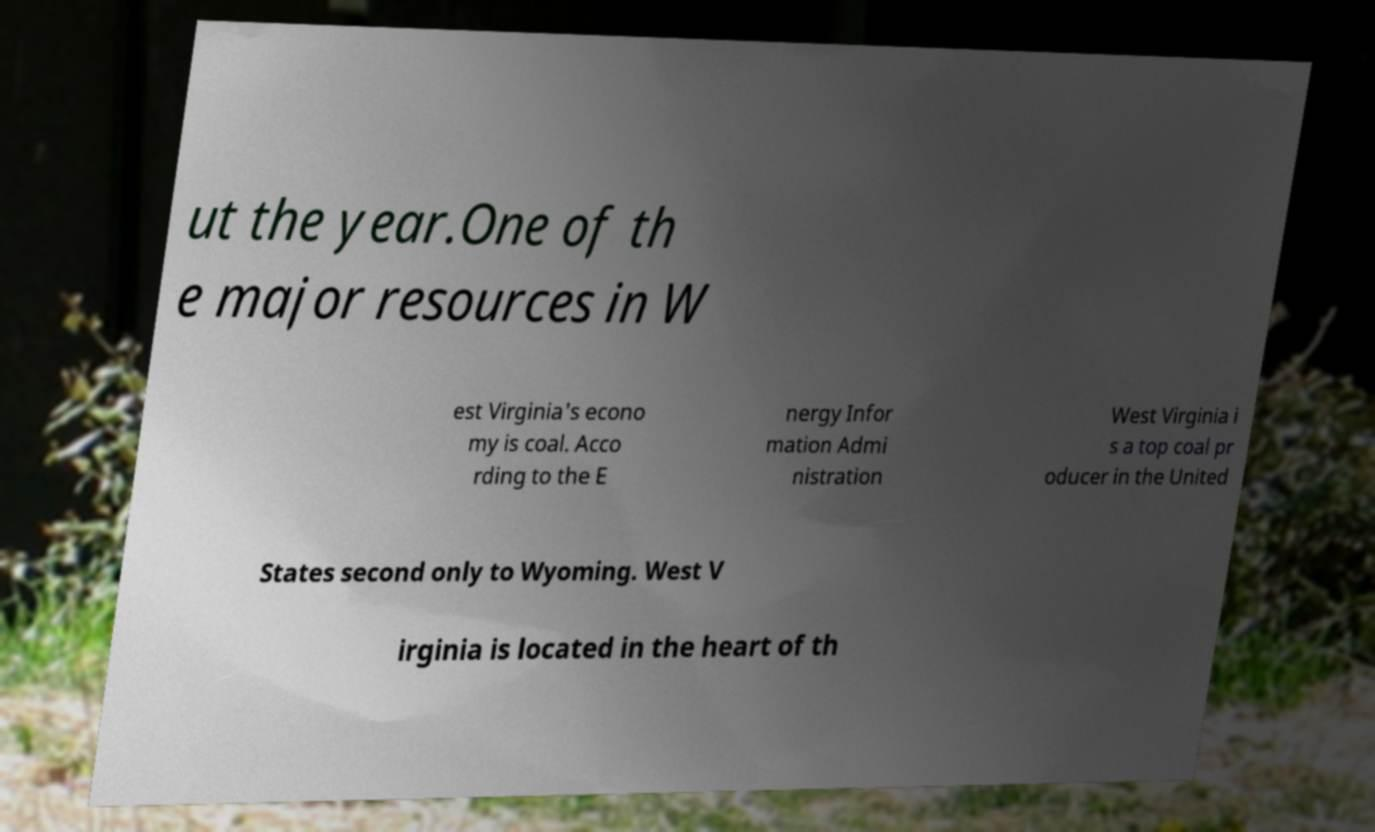There's text embedded in this image that I need extracted. Can you transcribe it verbatim? ut the year.One of th e major resources in W est Virginia's econo my is coal. Acco rding to the E nergy Infor mation Admi nistration West Virginia i s a top coal pr oducer in the United States second only to Wyoming. West V irginia is located in the heart of th 